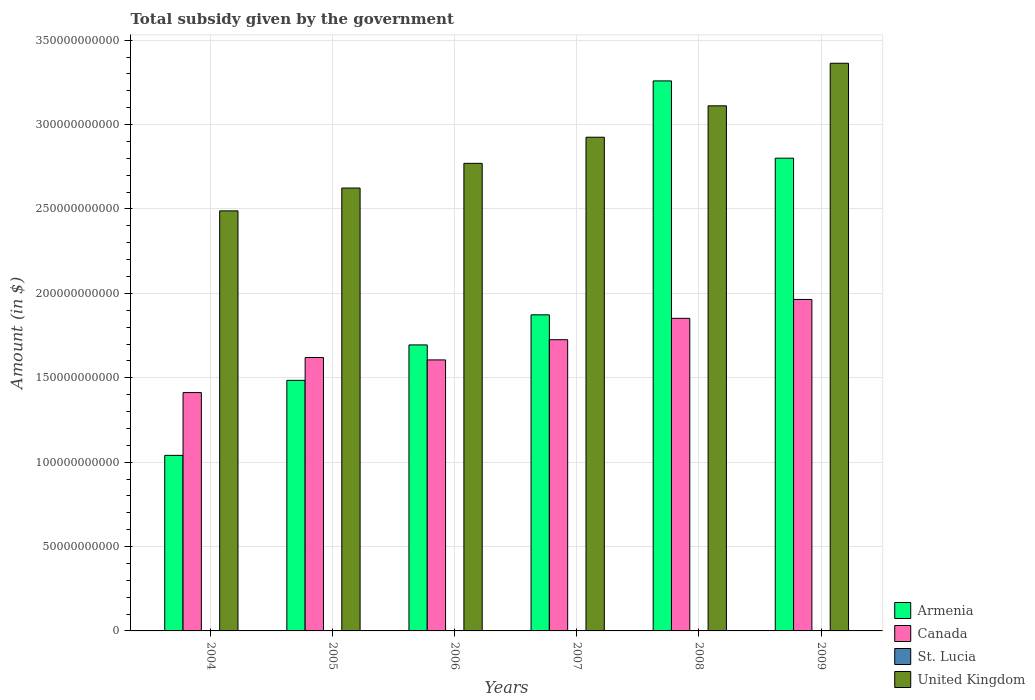How many different coloured bars are there?
Your response must be concise. 4. How many groups of bars are there?
Your answer should be very brief. 6. Are the number of bars per tick equal to the number of legend labels?
Provide a short and direct response. Yes. How many bars are there on the 4th tick from the left?
Offer a terse response. 4. What is the total revenue collected by the government in Armenia in 2004?
Offer a terse response. 1.04e+11. Across all years, what is the maximum total revenue collected by the government in Canada?
Your response must be concise. 1.96e+11. Across all years, what is the minimum total revenue collected by the government in United Kingdom?
Make the answer very short. 2.49e+11. In which year was the total revenue collected by the government in Canada maximum?
Make the answer very short. 2009. In which year was the total revenue collected by the government in Canada minimum?
Your answer should be very brief. 2004. What is the total total revenue collected by the government in United Kingdom in the graph?
Provide a short and direct response. 1.73e+12. What is the difference between the total revenue collected by the government in Armenia in 2005 and that in 2009?
Your answer should be compact. -1.32e+11. What is the difference between the total revenue collected by the government in Canada in 2008 and the total revenue collected by the government in St. Lucia in 2009?
Give a very brief answer. 1.85e+11. What is the average total revenue collected by the government in Canada per year?
Your answer should be compact. 1.70e+11. In the year 2005, what is the difference between the total revenue collected by the government in Armenia and total revenue collected by the government in St. Lucia?
Provide a succinct answer. 1.48e+11. In how many years, is the total revenue collected by the government in Canada greater than 140000000000 $?
Make the answer very short. 6. What is the ratio of the total revenue collected by the government in United Kingdom in 2008 to that in 2009?
Give a very brief answer. 0.93. What is the difference between the highest and the second highest total revenue collected by the government in United Kingdom?
Keep it short and to the point. 2.52e+1. What is the difference between the highest and the lowest total revenue collected by the government in Armenia?
Offer a terse response. 2.22e+11. Is the sum of the total revenue collected by the government in United Kingdom in 2004 and 2006 greater than the maximum total revenue collected by the government in Canada across all years?
Provide a succinct answer. Yes. Is it the case that in every year, the sum of the total revenue collected by the government in St. Lucia and total revenue collected by the government in Canada is greater than the sum of total revenue collected by the government in United Kingdom and total revenue collected by the government in Armenia?
Offer a terse response. Yes. What does the 4th bar from the left in 2004 represents?
Give a very brief answer. United Kingdom. What does the 1st bar from the right in 2006 represents?
Your answer should be very brief. United Kingdom. Is it the case that in every year, the sum of the total revenue collected by the government in St. Lucia and total revenue collected by the government in Canada is greater than the total revenue collected by the government in United Kingdom?
Provide a short and direct response. No. How many bars are there?
Offer a terse response. 24. Are all the bars in the graph horizontal?
Offer a very short reply. No. How many years are there in the graph?
Keep it short and to the point. 6. Are the values on the major ticks of Y-axis written in scientific E-notation?
Your answer should be very brief. No. How many legend labels are there?
Your response must be concise. 4. What is the title of the graph?
Offer a terse response. Total subsidy given by the government. Does "Belarus" appear as one of the legend labels in the graph?
Make the answer very short. No. What is the label or title of the X-axis?
Make the answer very short. Years. What is the label or title of the Y-axis?
Keep it short and to the point. Amount (in $). What is the Amount (in $) in Armenia in 2004?
Your answer should be very brief. 1.04e+11. What is the Amount (in $) in Canada in 2004?
Your response must be concise. 1.41e+11. What is the Amount (in $) of St. Lucia in 2004?
Offer a terse response. 1.06e+08. What is the Amount (in $) in United Kingdom in 2004?
Your answer should be very brief. 2.49e+11. What is the Amount (in $) of Armenia in 2005?
Your answer should be compact. 1.48e+11. What is the Amount (in $) in Canada in 2005?
Offer a very short reply. 1.62e+11. What is the Amount (in $) in St. Lucia in 2005?
Provide a succinct answer. 9.65e+07. What is the Amount (in $) of United Kingdom in 2005?
Give a very brief answer. 2.62e+11. What is the Amount (in $) of Armenia in 2006?
Make the answer very short. 1.69e+11. What is the Amount (in $) in Canada in 2006?
Offer a terse response. 1.61e+11. What is the Amount (in $) of St. Lucia in 2006?
Keep it short and to the point. 4.63e+07. What is the Amount (in $) of United Kingdom in 2006?
Provide a succinct answer. 2.77e+11. What is the Amount (in $) in Armenia in 2007?
Make the answer very short. 1.87e+11. What is the Amount (in $) of Canada in 2007?
Your answer should be very brief. 1.73e+11. What is the Amount (in $) of St. Lucia in 2007?
Ensure brevity in your answer.  4.54e+07. What is the Amount (in $) of United Kingdom in 2007?
Ensure brevity in your answer.  2.93e+11. What is the Amount (in $) of Armenia in 2008?
Your answer should be compact. 3.26e+11. What is the Amount (in $) of Canada in 2008?
Ensure brevity in your answer.  1.85e+11. What is the Amount (in $) in St. Lucia in 2008?
Make the answer very short. 1.28e+08. What is the Amount (in $) of United Kingdom in 2008?
Make the answer very short. 3.11e+11. What is the Amount (in $) of Armenia in 2009?
Provide a short and direct response. 2.80e+11. What is the Amount (in $) in Canada in 2009?
Ensure brevity in your answer.  1.96e+11. What is the Amount (in $) of St. Lucia in 2009?
Keep it short and to the point. 1.28e+08. What is the Amount (in $) in United Kingdom in 2009?
Keep it short and to the point. 3.36e+11. Across all years, what is the maximum Amount (in $) of Armenia?
Ensure brevity in your answer.  3.26e+11. Across all years, what is the maximum Amount (in $) of Canada?
Offer a very short reply. 1.96e+11. Across all years, what is the maximum Amount (in $) in St. Lucia?
Your answer should be compact. 1.28e+08. Across all years, what is the maximum Amount (in $) of United Kingdom?
Make the answer very short. 3.36e+11. Across all years, what is the minimum Amount (in $) in Armenia?
Ensure brevity in your answer.  1.04e+11. Across all years, what is the minimum Amount (in $) in Canada?
Your answer should be very brief. 1.41e+11. Across all years, what is the minimum Amount (in $) in St. Lucia?
Your answer should be very brief. 4.54e+07. Across all years, what is the minimum Amount (in $) of United Kingdom?
Offer a terse response. 2.49e+11. What is the total Amount (in $) of Armenia in the graph?
Ensure brevity in your answer.  1.22e+12. What is the total Amount (in $) of Canada in the graph?
Your answer should be compact. 1.02e+12. What is the total Amount (in $) in St. Lucia in the graph?
Make the answer very short. 5.50e+08. What is the total Amount (in $) of United Kingdom in the graph?
Your response must be concise. 1.73e+12. What is the difference between the Amount (in $) in Armenia in 2004 and that in 2005?
Offer a very short reply. -4.45e+1. What is the difference between the Amount (in $) of Canada in 2004 and that in 2005?
Provide a succinct answer. -2.08e+1. What is the difference between the Amount (in $) in St. Lucia in 2004 and that in 2005?
Your answer should be compact. 9.50e+06. What is the difference between the Amount (in $) of United Kingdom in 2004 and that in 2005?
Your answer should be compact. -1.35e+1. What is the difference between the Amount (in $) of Armenia in 2004 and that in 2006?
Keep it short and to the point. -6.54e+1. What is the difference between the Amount (in $) in Canada in 2004 and that in 2006?
Keep it short and to the point. -1.94e+1. What is the difference between the Amount (in $) in St. Lucia in 2004 and that in 2006?
Offer a terse response. 5.97e+07. What is the difference between the Amount (in $) in United Kingdom in 2004 and that in 2006?
Your response must be concise. -2.82e+1. What is the difference between the Amount (in $) in Armenia in 2004 and that in 2007?
Make the answer very short. -8.33e+1. What is the difference between the Amount (in $) in Canada in 2004 and that in 2007?
Offer a very short reply. -3.13e+1. What is the difference between the Amount (in $) of St. Lucia in 2004 and that in 2007?
Offer a very short reply. 6.06e+07. What is the difference between the Amount (in $) of United Kingdom in 2004 and that in 2007?
Offer a terse response. -4.36e+1. What is the difference between the Amount (in $) of Armenia in 2004 and that in 2008?
Keep it short and to the point. -2.22e+11. What is the difference between the Amount (in $) in Canada in 2004 and that in 2008?
Keep it short and to the point. -4.40e+1. What is the difference between the Amount (in $) of St. Lucia in 2004 and that in 2008?
Provide a short and direct response. -2.17e+07. What is the difference between the Amount (in $) of United Kingdom in 2004 and that in 2008?
Your answer should be compact. -6.22e+1. What is the difference between the Amount (in $) in Armenia in 2004 and that in 2009?
Your answer should be compact. -1.76e+11. What is the difference between the Amount (in $) of Canada in 2004 and that in 2009?
Your answer should be compact. -5.52e+1. What is the difference between the Amount (in $) of St. Lucia in 2004 and that in 2009?
Provide a short and direct response. -2.20e+07. What is the difference between the Amount (in $) of United Kingdom in 2004 and that in 2009?
Make the answer very short. -8.75e+1. What is the difference between the Amount (in $) of Armenia in 2005 and that in 2006?
Give a very brief answer. -2.10e+1. What is the difference between the Amount (in $) in Canada in 2005 and that in 2006?
Your answer should be compact. 1.41e+09. What is the difference between the Amount (in $) of St. Lucia in 2005 and that in 2006?
Provide a succinct answer. 5.02e+07. What is the difference between the Amount (in $) of United Kingdom in 2005 and that in 2006?
Provide a succinct answer. -1.46e+1. What is the difference between the Amount (in $) of Armenia in 2005 and that in 2007?
Your answer should be very brief. -3.88e+1. What is the difference between the Amount (in $) in Canada in 2005 and that in 2007?
Ensure brevity in your answer.  -1.06e+1. What is the difference between the Amount (in $) in St. Lucia in 2005 and that in 2007?
Provide a short and direct response. 5.11e+07. What is the difference between the Amount (in $) of United Kingdom in 2005 and that in 2007?
Ensure brevity in your answer.  -3.01e+1. What is the difference between the Amount (in $) of Armenia in 2005 and that in 2008?
Offer a terse response. -1.77e+11. What is the difference between the Amount (in $) of Canada in 2005 and that in 2008?
Keep it short and to the point. -2.32e+1. What is the difference between the Amount (in $) in St. Lucia in 2005 and that in 2008?
Provide a short and direct response. -3.12e+07. What is the difference between the Amount (in $) of United Kingdom in 2005 and that in 2008?
Offer a terse response. -4.87e+1. What is the difference between the Amount (in $) in Armenia in 2005 and that in 2009?
Provide a succinct answer. -1.32e+11. What is the difference between the Amount (in $) of Canada in 2005 and that in 2009?
Your answer should be very brief. -3.44e+1. What is the difference between the Amount (in $) of St. Lucia in 2005 and that in 2009?
Offer a terse response. -3.15e+07. What is the difference between the Amount (in $) in United Kingdom in 2005 and that in 2009?
Provide a succinct answer. -7.39e+1. What is the difference between the Amount (in $) of Armenia in 2006 and that in 2007?
Your answer should be compact. -1.78e+1. What is the difference between the Amount (in $) of Canada in 2006 and that in 2007?
Ensure brevity in your answer.  -1.20e+1. What is the difference between the Amount (in $) of St. Lucia in 2006 and that in 2007?
Ensure brevity in your answer.  9.00e+05. What is the difference between the Amount (in $) in United Kingdom in 2006 and that in 2007?
Provide a short and direct response. -1.55e+1. What is the difference between the Amount (in $) of Armenia in 2006 and that in 2008?
Provide a short and direct response. -1.56e+11. What is the difference between the Amount (in $) of Canada in 2006 and that in 2008?
Keep it short and to the point. -2.46e+1. What is the difference between the Amount (in $) in St. Lucia in 2006 and that in 2008?
Keep it short and to the point. -8.14e+07. What is the difference between the Amount (in $) in United Kingdom in 2006 and that in 2008?
Provide a short and direct response. -3.41e+1. What is the difference between the Amount (in $) of Armenia in 2006 and that in 2009?
Your answer should be compact. -1.11e+11. What is the difference between the Amount (in $) of Canada in 2006 and that in 2009?
Give a very brief answer. -3.58e+1. What is the difference between the Amount (in $) in St. Lucia in 2006 and that in 2009?
Your answer should be compact. -8.17e+07. What is the difference between the Amount (in $) in United Kingdom in 2006 and that in 2009?
Give a very brief answer. -5.93e+1. What is the difference between the Amount (in $) in Armenia in 2007 and that in 2008?
Give a very brief answer. -1.39e+11. What is the difference between the Amount (in $) of Canada in 2007 and that in 2008?
Keep it short and to the point. -1.27e+1. What is the difference between the Amount (in $) of St. Lucia in 2007 and that in 2008?
Your answer should be compact. -8.23e+07. What is the difference between the Amount (in $) of United Kingdom in 2007 and that in 2008?
Your answer should be very brief. -1.86e+1. What is the difference between the Amount (in $) in Armenia in 2007 and that in 2009?
Give a very brief answer. -9.28e+1. What is the difference between the Amount (in $) of Canada in 2007 and that in 2009?
Provide a succinct answer. -2.39e+1. What is the difference between the Amount (in $) of St. Lucia in 2007 and that in 2009?
Provide a succinct answer. -8.26e+07. What is the difference between the Amount (in $) of United Kingdom in 2007 and that in 2009?
Offer a very short reply. -4.38e+1. What is the difference between the Amount (in $) in Armenia in 2008 and that in 2009?
Offer a terse response. 4.58e+1. What is the difference between the Amount (in $) in Canada in 2008 and that in 2009?
Offer a terse response. -1.12e+1. What is the difference between the Amount (in $) in United Kingdom in 2008 and that in 2009?
Offer a terse response. -2.52e+1. What is the difference between the Amount (in $) of Armenia in 2004 and the Amount (in $) of Canada in 2005?
Provide a succinct answer. -5.80e+1. What is the difference between the Amount (in $) in Armenia in 2004 and the Amount (in $) in St. Lucia in 2005?
Provide a short and direct response. 1.04e+11. What is the difference between the Amount (in $) in Armenia in 2004 and the Amount (in $) in United Kingdom in 2005?
Provide a short and direct response. -1.58e+11. What is the difference between the Amount (in $) of Canada in 2004 and the Amount (in $) of St. Lucia in 2005?
Keep it short and to the point. 1.41e+11. What is the difference between the Amount (in $) in Canada in 2004 and the Amount (in $) in United Kingdom in 2005?
Your answer should be compact. -1.21e+11. What is the difference between the Amount (in $) in St. Lucia in 2004 and the Amount (in $) in United Kingdom in 2005?
Offer a very short reply. -2.62e+11. What is the difference between the Amount (in $) in Armenia in 2004 and the Amount (in $) in Canada in 2006?
Provide a succinct answer. -5.66e+1. What is the difference between the Amount (in $) in Armenia in 2004 and the Amount (in $) in St. Lucia in 2006?
Give a very brief answer. 1.04e+11. What is the difference between the Amount (in $) of Armenia in 2004 and the Amount (in $) of United Kingdom in 2006?
Your response must be concise. -1.73e+11. What is the difference between the Amount (in $) of Canada in 2004 and the Amount (in $) of St. Lucia in 2006?
Provide a succinct answer. 1.41e+11. What is the difference between the Amount (in $) of Canada in 2004 and the Amount (in $) of United Kingdom in 2006?
Give a very brief answer. -1.36e+11. What is the difference between the Amount (in $) of St. Lucia in 2004 and the Amount (in $) of United Kingdom in 2006?
Your answer should be very brief. -2.77e+11. What is the difference between the Amount (in $) of Armenia in 2004 and the Amount (in $) of Canada in 2007?
Make the answer very short. -6.85e+1. What is the difference between the Amount (in $) in Armenia in 2004 and the Amount (in $) in St. Lucia in 2007?
Your answer should be compact. 1.04e+11. What is the difference between the Amount (in $) of Armenia in 2004 and the Amount (in $) of United Kingdom in 2007?
Offer a terse response. -1.88e+11. What is the difference between the Amount (in $) in Canada in 2004 and the Amount (in $) in St. Lucia in 2007?
Make the answer very short. 1.41e+11. What is the difference between the Amount (in $) in Canada in 2004 and the Amount (in $) in United Kingdom in 2007?
Make the answer very short. -1.51e+11. What is the difference between the Amount (in $) in St. Lucia in 2004 and the Amount (in $) in United Kingdom in 2007?
Your answer should be very brief. -2.92e+11. What is the difference between the Amount (in $) of Armenia in 2004 and the Amount (in $) of Canada in 2008?
Give a very brief answer. -8.12e+1. What is the difference between the Amount (in $) in Armenia in 2004 and the Amount (in $) in St. Lucia in 2008?
Ensure brevity in your answer.  1.04e+11. What is the difference between the Amount (in $) in Armenia in 2004 and the Amount (in $) in United Kingdom in 2008?
Your answer should be very brief. -2.07e+11. What is the difference between the Amount (in $) of Canada in 2004 and the Amount (in $) of St. Lucia in 2008?
Your response must be concise. 1.41e+11. What is the difference between the Amount (in $) in Canada in 2004 and the Amount (in $) in United Kingdom in 2008?
Your response must be concise. -1.70e+11. What is the difference between the Amount (in $) of St. Lucia in 2004 and the Amount (in $) of United Kingdom in 2008?
Make the answer very short. -3.11e+11. What is the difference between the Amount (in $) of Armenia in 2004 and the Amount (in $) of Canada in 2009?
Give a very brief answer. -9.24e+1. What is the difference between the Amount (in $) in Armenia in 2004 and the Amount (in $) in St. Lucia in 2009?
Give a very brief answer. 1.04e+11. What is the difference between the Amount (in $) of Armenia in 2004 and the Amount (in $) of United Kingdom in 2009?
Provide a succinct answer. -2.32e+11. What is the difference between the Amount (in $) in Canada in 2004 and the Amount (in $) in St. Lucia in 2009?
Your answer should be compact. 1.41e+11. What is the difference between the Amount (in $) of Canada in 2004 and the Amount (in $) of United Kingdom in 2009?
Your answer should be very brief. -1.95e+11. What is the difference between the Amount (in $) of St. Lucia in 2004 and the Amount (in $) of United Kingdom in 2009?
Your response must be concise. -3.36e+11. What is the difference between the Amount (in $) in Armenia in 2005 and the Amount (in $) in Canada in 2006?
Your answer should be very brief. -1.21e+1. What is the difference between the Amount (in $) in Armenia in 2005 and the Amount (in $) in St. Lucia in 2006?
Your response must be concise. 1.48e+11. What is the difference between the Amount (in $) in Armenia in 2005 and the Amount (in $) in United Kingdom in 2006?
Provide a short and direct response. -1.29e+11. What is the difference between the Amount (in $) in Canada in 2005 and the Amount (in $) in St. Lucia in 2006?
Your answer should be very brief. 1.62e+11. What is the difference between the Amount (in $) of Canada in 2005 and the Amount (in $) of United Kingdom in 2006?
Give a very brief answer. -1.15e+11. What is the difference between the Amount (in $) in St. Lucia in 2005 and the Amount (in $) in United Kingdom in 2006?
Provide a succinct answer. -2.77e+11. What is the difference between the Amount (in $) of Armenia in 2005 and the Amount (in $) of Canada in 2007?
Your answer should be very brief. -2.41e+1. What is the difference between the Amount (in $) in Armenia in 2005 and the Amount (in $) in St. Lucia in 2007?
Keep it short and to the point. 1.48e+11. What is the difference between the Amount (in $) in Armenia in 2005 and the Amount (in $) in United Kingdom in 2007?
Provide a short and direct response. -1.44e+11. What is the difference between the Amount (in $) in Canada in 2005 and the Amount (in $) in St. Lucia in 2007?
Offer a terse response. 1.62e+11. What is the difference between the Amount (in $) of Canada in 2005 and the Amount (in $) of United Kingdom in 2007?
Keep it short and to the point. -1.31e+11. What is the difference between the Amount (in $) in St. Lucia in 2005 and the Amount (in $) in United Kingdom in 2007?
Offer a terse response. -2.92e+11. What is the difference between the Amount (in $) in Armenia in 2005 and the Amount (in $) in Canada in 2008?
Give a very brief answer. -3.67e+1. What is the difference between the Amount (in $) of Armenia in 2005 and the Amount (in $) of St. Lucia in 2008?
Provide a short and direct response. 1.48e+11. What is the difference between the Amount (in $) in Armenia in 2005 and the Amount (in $) in United Kingdom in 2008?
Your response must be concise. -1.63e+11. What is the difference between the Amount (in $) in Canada in 2005 and the Amount (in $) in St. Lucia in 2008?
Provide a succinct answer. 1.62e+11. What is the difference between the Amount (in $) in Canada in 2005 and the Amount (in $) in United Kingdom in 2008?
Keep it short and to the point. -1.49e+11. What is the difference between the Amount (in $) of St. Lucia in 2005 and the Amount (in $) of United Kingdom in 2008?
Give a very brief answer. -3.11e+11. What is the difference between the Amount (in $) of Armenia in 2005 and the Amount (in $) of Canada in 2009?
Your answer should be compact. -4.79e+1. What is the difference between the Amount (in $) of Armenia in 2005 and the Amount (in $) of St. Lucia in 2009?
Keep it short and to the point. 1.48e+11. What is the difference between the Amount (in $) of Armenia in 2005 and the Amount (in $) of United Kingdom in 2009?
Make the answer very short. -1.88e+11. What is the difference between the Amount (in $) in Canada in 2005 and the Amount (in $) in St. Lucia in 2009?
Your answer should be very brief. 1.62e+11. What is the difference between the Amount (in $) of Canada in 2005 and the Amount (in $) of United Kingdom in 2009?
Make the answer very short. -1.74e+11. What is the difference between the Amount (in $) of St. Lucia in 2005 and the Amount (in $) of United Kingdom in 2009?
Make the answer very short. -3.36e+11. What is the difference between the Amount (in $) in Armenia in 2006 and the Amount (in $) in Canada in 2007?
Your answer should be very brief. -3.09e+09. What is the difference between the Amount (in $) of Armenia in 2006 and the Amount (in $) of St. Lucia in 2007?
Offer a very short reply. 1.69e+11. What is the difference between the Amount (in $) in Armenia in 2006 and the Amount (in $) in United Kingdom in 2007?
Keep it short and to the point. -1.23e+11. What is the difference between the Amount (in $) in Canada in 2006 and the Amount (in $) in St. Lucia in 2007?
Ensure brevity in your answer.  1.61e+11. What is the difference between the Amount (in $) of Canada in 2006 and the Amount (in $) of United Kingdom in 2007?
Give a very brief answer. -1.32e+11. What is the difference between the Amount (in $) in St. Lucia in 2006 and the Amount (in $) in United Kingdom in 2007?
Make the answer very short. -2.92e+11. What is the difference between the Amount (in $) in Armenia in 2006 and the Amount (in $) in Canada in 2008?
Your answer should be very brief. -1.57e+1. What is the difference between the Amount (in $) in Armenia in 2006 and the Amount (in $) in St. Lucia in 2008?
Offer a very short reply. 1.69e+11. What is the difference between the Amount (in $) in Armenia in 2006 and the Amount (in $) in United Kingdom in 2008?
Provide a short and direct response. -1.42e+11. What is the difference between the Amount (in $) of Canada in 2006 and the Amount (in $) of St. Lucia in 2008?
Your answer should be very brief. 1.60e+11. What is the difference between the Amount (in $) in Canada in 2006 and the Amount (in $) in United Kingdom in 2008?
Provide a short and direct response. -1.51e+11. What is the difference between the Amount (in $) of St. Lucia in 2006 and the Amount (in $) of United Kingdom in 2008?
Your answer should be compact. -3.11e+11. What is the difference between the Amount (in $) of Armenia in 2006 and the Amount (in $) of Canada in 2009?
Your response must be concise. -2.69e+1. What is the difference between the Amount (in $) of Armenia in 2006 and the Amount (in $) of St. Lucia in 2009?
Offer a very short reply. 1.69e+11. What is the difference between the Amount (in $) of Armenia in 2006 and the Amount (in $) of United Kingdom in 2009?
Provide a short and direct response. -1.67e+11. What is the difference between the Amount (in $) of Canada in 2006 and the Amount (in $) of St. Lucia in 2009?
Your answer should be very brief. 1.60e+11. What is the difference between the Amount (in $) in Canada in 2006 and the Amount (in $) in United Kingdom in 2009?
Keep it short and to the point. -1.76e+11. What is the difference between the Amount (in $) in St. Lucia in 2006 and the Amount (in $) in United Kingdom in 2009?
Provide a succinct answer. -3.36e+11. What is the difference between the Amount (in $) in Armenia in 2007 and the Amount (in $) in Canada in 2008?
Your response must be concise. 2.08e+09. What is the difference between the Amount (in $) of Armenia in 2007 and the Amount (in $) of St. Lucia in 2008?
Provide a succinct answer. 1.87e+11. What is the difference between the Amount (in $) of Armenia in 2007 and the Amount (in $) of United Kingdom in 2008?
Your response must be concise. -1.24e+11. What is the difference between the Amount (in $) in Canada in 2007 and the Amount (in $) in St. Lucia in 2008?
Make the answer very short. 1.72e+11. What is the difference between the Amount (in $) in Canada in 2007 and the Amount (in $) in United Kingdom in 2008?
Make the answer very short. -1.39e+11. What is the difference between the Amount (in $) of St. Lucia in 2007 and the Amount (in $) of United Kingdom in 2008?
Your answer should be compact. -3.11e+11. What is the difference between the Amount (in $) of Armenia in 2007 and the Amount (in $) of Canada in 2009?
Your answer should be very brief. -9.12e+09. What is the difference between the Amount (in $) in Armenia in 2007 and the Amount (in $) in St. Lucia in 2009?
Offer a very short reply. 1.87e+11. What is the difference between the Amount (in $) in Armenia in 2007 and the Amount (in $) in United Kingdom in 2009?
Provide a short and direct response. -1.49e+11. What is the difference between the Amount (in $) in Canada in 2007 and the Amount (in $) in St. Lucia in 2009?
Your answer should be very brief. 1.72e+11. What is the difference between the Amount (in $) of Canada in 2007 and the Amount (in $) of United Kingdom in 2009?
Your response must be concise. -1.64e+11. What is the difference between the Amount (in $) of St. Lucia in 2007 and the Amount (in $) of United Kingdom in 2009?
Your response must be concise. -3.36e+11. What is the difference between the Amount (in $) of Armenia in 2008 and the Amount (in $) of Canada in 2009?
Make the answer very short. 1.29e+11. What is the difference between the Amount (in $) of Armenia in 2008 and the Amount (in $) of St. Lucia in 2009?
Your answer should be compact. 3.26e+11. What is the difference between the Amount (in $) in Armenia in 2008 and the Amount (in $) in United Kingdom in 2009?
Provide a succinct answer. -1.05e+1. What is the difference between the Amount (in $) in Canada in 2008 and the Amount (in $) in St. Lucia in 2009?
Provide a short and direct response. 1.85e+11. What is the difference between the Amount (in $) of Canada in 2008 and the Amount (in $) of United Kingdom in 2009?
Your answer should be compact. -1.51e+11. What is the difference between the Amount (in $) of St. Lucia in 2008 and the Amount (in $) of United Kingdom in 2009?
Provide a short and direct response. -3.36e+11. What is the average Amount (in $) in Armenia per year?
Keep it short and to the point. 2.03e+11. What is the average Amount (in $) of Canada per year?
Give a very brief answer. 1.70e+11. What is the average Amount (in $) of St. Lucia per year?
Your response must be concise. 9.16e+07. What is the average Amount (in $) in United Kingdom per year?
Give a very brief answer. 2.88e+11. In the year 2004, what is the difference between the Amount (in $) in Armenia and Amount (in $) in Canada?
Provide a short and direct response. -3.72e+1. In the year 2004, what is the difference between the Amount (in $) in Armenia and Amount (in $) in St. Lucia?
Offer a very short reply. 1.04e+11. In the year 2004, what is the difference between the Amount (in $) in Armenia and Amount (in $) in United Kingdom?
Provide a succinct answer. -1.45e+11. In the year 2004, what is the difference between the Amount (in $) in Canada and Amount (in $) in St. Lucia?
Give a very brief answer. 1.41e+11. In the year 2004, what is the difference between the Amount (in $) in Canada and Amount (in $) in United Kingdom?
Provide a short and direct response. -1.08e+11. In the year 2004, what is the difference between the Amount (in $) of St. Lucia and Amount (in $) of United Kingdom?
Your answer should be very brief. -2.49e+11. In the year 2005, what is the difference between the Amount (in $) of Armenia and Amount (in $) of Canada?
Keep it short and to the point. -1.35e+1. In the year 2005, what is the difference between the Amount (in $) in Armenia and Amount (in $) in St. Lucia?
Provide a short and direct response. 1.48e+11. In the year 2005, what is the difference between the Amount (in $) in Armenia and Amount (in $) in United Kingdom?
Make the answer very short. -1.14e+11. In the year 2005, what is the difference between the Amount (in $) in Canada and Amount (in $) in St. Lucia?
Your answer should be very brief. 1.62e+11. In the year 2005, what is the difference between the Amount (in $) in Canada and Amount (in $) in United Kingdom?
Provide a short and direct response. -1.00e+11. In the year 2005, what is the difference between the Amount (in $) in St. Lucia and Amount (in $) in United Kingdom?
Provide a succinct answer. -2.62e+11. In the year 2006, what is the difference between the Amount (in $) of Armenia and Amount (in $) of Canada?
Give a very brief answer. 8.89e+09. In the year 2006, what is the difference between the Amount (in $) of Armenia and Amount (in $) of St. Lucia?
Provide a succinct answer. 1.69e+11. In the year 2006, what is the difference between the Amount (in $) in Armenia and Amount (in $) in United Kingdom?
Your answer should be very brief. -1.08e+11. In the year 2006, what is the difference between the Amount (in $) of Canada and Amount (in $) of St. Lucia?
Ensure brevity in your answer.  1.61e+11. In the year 2006, what is the difference between the Amount (in $) in Canada and Amount (in $) in United Kingdom?
Your answer should be very brief. -1.16e+11. In the year 2006, what is the difference between the Amount (in $) in St. Lucia and Amount (in $) in United Kingdom?
Your answer should be compact. -2.77e+11. In the year 2007, what is the difference between the Amount (in $) in Armenia and Amount (in $) in Canada?
Your answer should be very brief. 1.47e+1. In the year 2007, what is the difference between the Amount (in $) in Armenia and Amount (in $) in St. Lucia?
Provide a succinct answer. 1.87e+11. In the year 2007, what is the difference between the Amount (in $) in Armenia and Amount (in $) in United Kingdom?
Your answer should be very brief. -1.05e+11. In the year 2007, what is the difference between the Amount (in $) in Canada and Amount (in $) in St. Lucia?
Give a very brief answer. 1.73e+11. In the year 2007, what is the difference between the Amount (in $) of Canada and Amount (in $) of United Kingdom?
Give a very brief answer. -1.20e+11. In the year 2007, what is the difference between the Amount (in $) in St. Lucia and Amount (in $) in United Kingdom?
Make the answer very short. -2.92e+11. In the year 2008, what is the difference between the Amount (in $) in Armenia and Amount (in $) in Canada?
Provide a succinct answer. 1.41e+11. In the year 2008, what is the difference between the Amount (in $) in Armenia and Amount (in $) in St. Lucia?
Your answer should be very brief. 3.26e+11. In the year 2008, what is the difference between the Amount (in $) of Armenia and Amount (in $) of United Kingdom?
Ensure brevity in your answer.  1.48e+1. In the year 2008, what is the difference between the Amount (in $) in Canada and Amount (in $) in St. Lucia?
Give a very brief answer. 1.85e+11. In the year 2008, what is the difference between the Amount (in $) of Canada and Amount (in $) of United Kingdom?
Ensure brevity in your answer.  -1.26e+11. In the year 2008, what is the difference between the Amount (in $) of St. Lucia and Amount (in $) of United Kingdom?
Your answer should be very brief. -3.11e+11. In the year 2009, what is the difference between the Amount (in $) of Armenia and Amount (in $) of Canada?
Make the answer very short. 8.37e+1. In the year 2009, what is the difference between the Amount (in $) of Armenia and Amount (in $) of St. Lucia?
Ensure brevity in your answer.  2.80e+11. In the year 2009, what is the difference between the Amount (in $) in Armenia and Amount (in $) in United Kingdom?
Your answer should be very brief. -5.62e+1. In the year 2009, what is the difference between the Amount (in $) of Canada and Amount (in $) of St. Lucia?
Provide a succinct answer. 1.96e+11. In the year 2009, what is the difference between the Amount (in $) in Canada and Amount (in $) in United Kingdom?
Offer a very short reply. -1.40e+11. In the year 2009, what is the difference between the Amount (in $) of St. Lucia and Amount (in $) of United Kingdom?
Give a very brief answer. -3.36e+11. What is the ratio of the Amount (in $) in Armenia in 2004 to that in 2005?
Provide a short and direct response. 0.7. What is the ratio of the Amount (in $) in Canada in 2004 to that in 2005?
Provide a succinct answer. 0.87. What is the ratio of the Amount (in $) in St. Lucia in 2004 to that in 2005?
Your answer should be very brief. 1.1. What is the ratio of the Amount (in $) in United Kingdom in 2004 to that in 2005?
Keep it short and to the point. 0.95. What is the ratio of the Amount (in $) in Armenia in 2004 to that in 2006?
Ensure brevity in your answer.  0.61. What is the ratio of the Amount (in $) of Canada in 2004 to that in 2006?
Keep it short and to the point. 0.88. What is the ratio of the Amount (in $) in St. Lucia in 2004 to that in 2006?
Offer a terse response. 2.29. What is the ratio of the Amount (in $) in United Kingdom in 2004 to that in 2006?
Your answer should be very brief. 0.9. What is the ratio of the Amount (in $) of Armenia in 2004 to that in 2007?
Your answer should be very brief. 0.56. What is the ratio of the Amount (in $) in Canada in 2004 to that in 2007?
Provide a succinct answer. 0.82. What is the ratio of the Amount (in $) in St. Lucia in 2004 to that in 2007?
Provide a succinct answer. 2.33. What is the ratio of the Amount (in $) of United Kingdom in 2004 to that in 2007?
Your answer should be very brief. 0.85. What is the ratio of the Amount (in $) of Armenia in 2004 to that in 2008?
Keep it short and to the point. 0.32. What is the ratio of the Amount (in $) in Canada in 2004 to that in 2008?
Your response must be concise. 0.76. What is the ratio of the Amount (in $) in St. Lucia in 2004 to that in 2008?
Provide a short and direct response. 0.83. What is the ratio of the Amount (in $) in United Kingdom in 2004 to that in 2008?
Make the answer very short. 0.8. What is the ratio of the Amount (in $) of Armenia in 2004 to that in 2009?
Provide a short and direct response. 0.37. What is the ratio of the Amount (in $) in Canada in 2004 to that in 2009?
Keep it short and to the point. 0.72. What is the ratio of the Amount (in $) of St. Lucia in 2004 to that in 2009?
Keep it short and to the point. 0.83. What is the ratio of the Amount (in $) in United Kingdom in 2004 to that in 2009?
Ensure brevity in your answer.  0.74. What is the ratio of the Amount (in $) of Armenia in 2005 to that in 2006?
Your response must be concise. 0.88. What is the ratio of the Amount (in $) of Canada in 2005 to that in 2006?
Make the answer very short. 1.01. What is the ratio of the Amount (in $) in St. Lucia in 2005 to that in 2006?
Your answer should be very brief. 2.08. What is the ratio of the Amount (in $) in United Kingdom in 2005 to that in 2006?
Offer a terse response. 0.95. What is the ratio of the Amount (in $) of Armenia in 2005 to that in 2007?
Give a very brief answer. 0.79. What is the ratio of the Amount (in $) in Canada in 2005 to that in 2007?
Make the answer very short. 0.94. What is the ratio of the Amount (in $) in St. Lucia in 2005 to that in 2007?
Keep it short and to the point. 2.13. What is the ratio of the Amount (in $) in United Kingdom in 2005 to that in 2007?
Offer a terse response. 0.9. What is the ratio of the Amount (in $) in Armenia in 2005 to that in 2008?
Make the answer very short. 0.46. What is the ratio of the Amount (in $) of Canada in 2005 to that in 2008?
Provide a short and direct response. 0.87. What is the ratio of the Amount (in $) of St. Lucia in 2005 to that in 2008?
Provide a succinct answer. 0.76. What is the ratio of the Amount (in $) of United Kingdom in 2005 to that in 2008?
Make the answer very short. 0.84. What is the ratio of the Amount (in $) in Armenia in 2005 to that in 2009?
Your response must be concise. 0.53. What is the ratio of the Amount (in $) in Canada in 2005 to that in 2009?
Keep it short and to the point. 0.82. What is the ratio of the Amount (in $) of St. Lucia in 2005 to that in 2009?
Your answer should be compact. 0.75. What is the ratio of the Amount (in $) in United Kingdom in 2005 to that in 2009?
Your answer should be compact. 0.78. What is the ratio of the Amount (in $) of Armenia in 2006 to that in 2007?
Your answer should be compact. 0.9. What is the ratio of the Amount (in $) in Canada in 2006 to that in 2007?
Keep it short and to the point. 0.93. What is the ratio of the Amount (in $) of St. Lucia in 2006 to that in 2007?
Give a very brief answer. 1.02. What is the ratio of the Amount (in $) of United Kingdom in 2006 to that in 2007?
Provide a short and direct response. 0.95. What is the ratio of the Amount (in $) of Armenia in 2006 to that in 2008?
Your response must be concise. 0.52. What is the ratio of the Amount (in $) in Canada in 2006 to that in 2008?
Provide a short and direct response. 0.87. What is the ratio of the Amount (in $) of St. Lucia in 2006 to that in 2008?
Ensure brevity in your answer.  0.36. What is the ratio of the Amount (in $) in United Kingdom in 2006 to that in 2008?
Offer a terse response. 0.89. What is the ratio of the Amount (in $) in Armenia in 2006 to that in 2009?
Provide a short and direct response. 0.6. What is the ratio of the Amount (in $) in Canada in 2006 to that in 2009?
Make the answer very short. 0.82. What is the ratio of the Amount (in $) in St. Lucia in 2006 to that in 2009?
Provide a succinct answer. 0.36. What is the ratio of the Amount (in $) of United Kingdom in 2006 to that in 2009?
Give a very brief answer. 0.82. What is the ratio of the Amount (in $) in Armenia in 2007 to that in 2008?
Ensure brevity in your answer.  0.57. What is the ratio of the Amount (in $) in Canada in 2007 to that in 2008?
Give a very brief answer. 0.93. What is the ratio of the Amount (in $) in St. Lucia in 2007 to that in 2008?
Ensure brevity in your answer.  0.36. What is the ratio of the Amount (in $) in United Kingdom in 2007 to that in 2008?
Your response must be concise. 0.94. What is the ratio of the Amount (in $) of Armenia in 2007 to that in 2009?
Offer a very short reply. 0.67. What is the ratio of the Amount (in $) of Canada in 2007 to that in 2009?
Your answer should be compact. 0.88. What is the ratio of the Amount (in $) of St. Lucia in 2007 to that in 2009?
Provide a short and direct response. 0.35. What is the ratio of the Amount (in $) in United Kingdom in 2007 to that in 2009?
Offer a terse response. 0.87. What is the ratio of the Amount (in $) of Armenia in 2008 to that in 2009?
Ensure brevity in your answer.  1.16. What is the ratio of the Amount (in $) in Canada in 2008 to that in 2009?
Make the answer very short. 0.94. What is the ratio of the Amount (in $) of St. Lucia in 2008 to that in 2009?
Provide a short and direct response. 1. What is the ratio of the Amount (in $) of United Kingdom in 2008 to that in 2009?
Make the answer very short. 0.93. What is the difference between the highest and the second highest Amount (in $) in Armenia?
Ensure brevity in your answer.  4.58e+1. What is the difference between the highest and the second highest Amount (in $) in Canada?
Ensure brevity in your answer.  1.12e+1. What is the difference between the highest and the second highest Amount (in $) in United Kingdom?
Offer a very short reply. 2.52e+1. What is the difference between the highest and the lowest Amount (in $) in Armenia?
Give a very brief answer. 2.22e+11. What is the difference between the highest and the lowest Amount (in $) in Canada?
Provide a short and direct response. 5.52e+1. What is the difference between the highest and the lowest Amount (in $) of St. Lucia?
Make the answer very short. 8.26e+07. What is the difference between the highest and the lowest Amount (in $) in United Kingdom?
Your answer should be compact. 8.75e+1. 